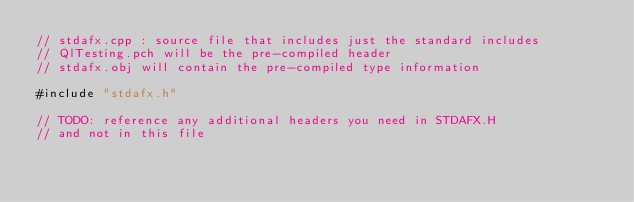<code> <loc_0><loc_0><loc_500><loc_500><_C++_>// stdafx.cpp : source file that includes just the standard includes
// QlTesting.pch will be the pre-compiled header
// stdafx.obj will contain the pre-compiled type information

#include "stdafx.h"

// TODO: reference any additional headers you need in STDAFX.H
// and not in this file
</code> 